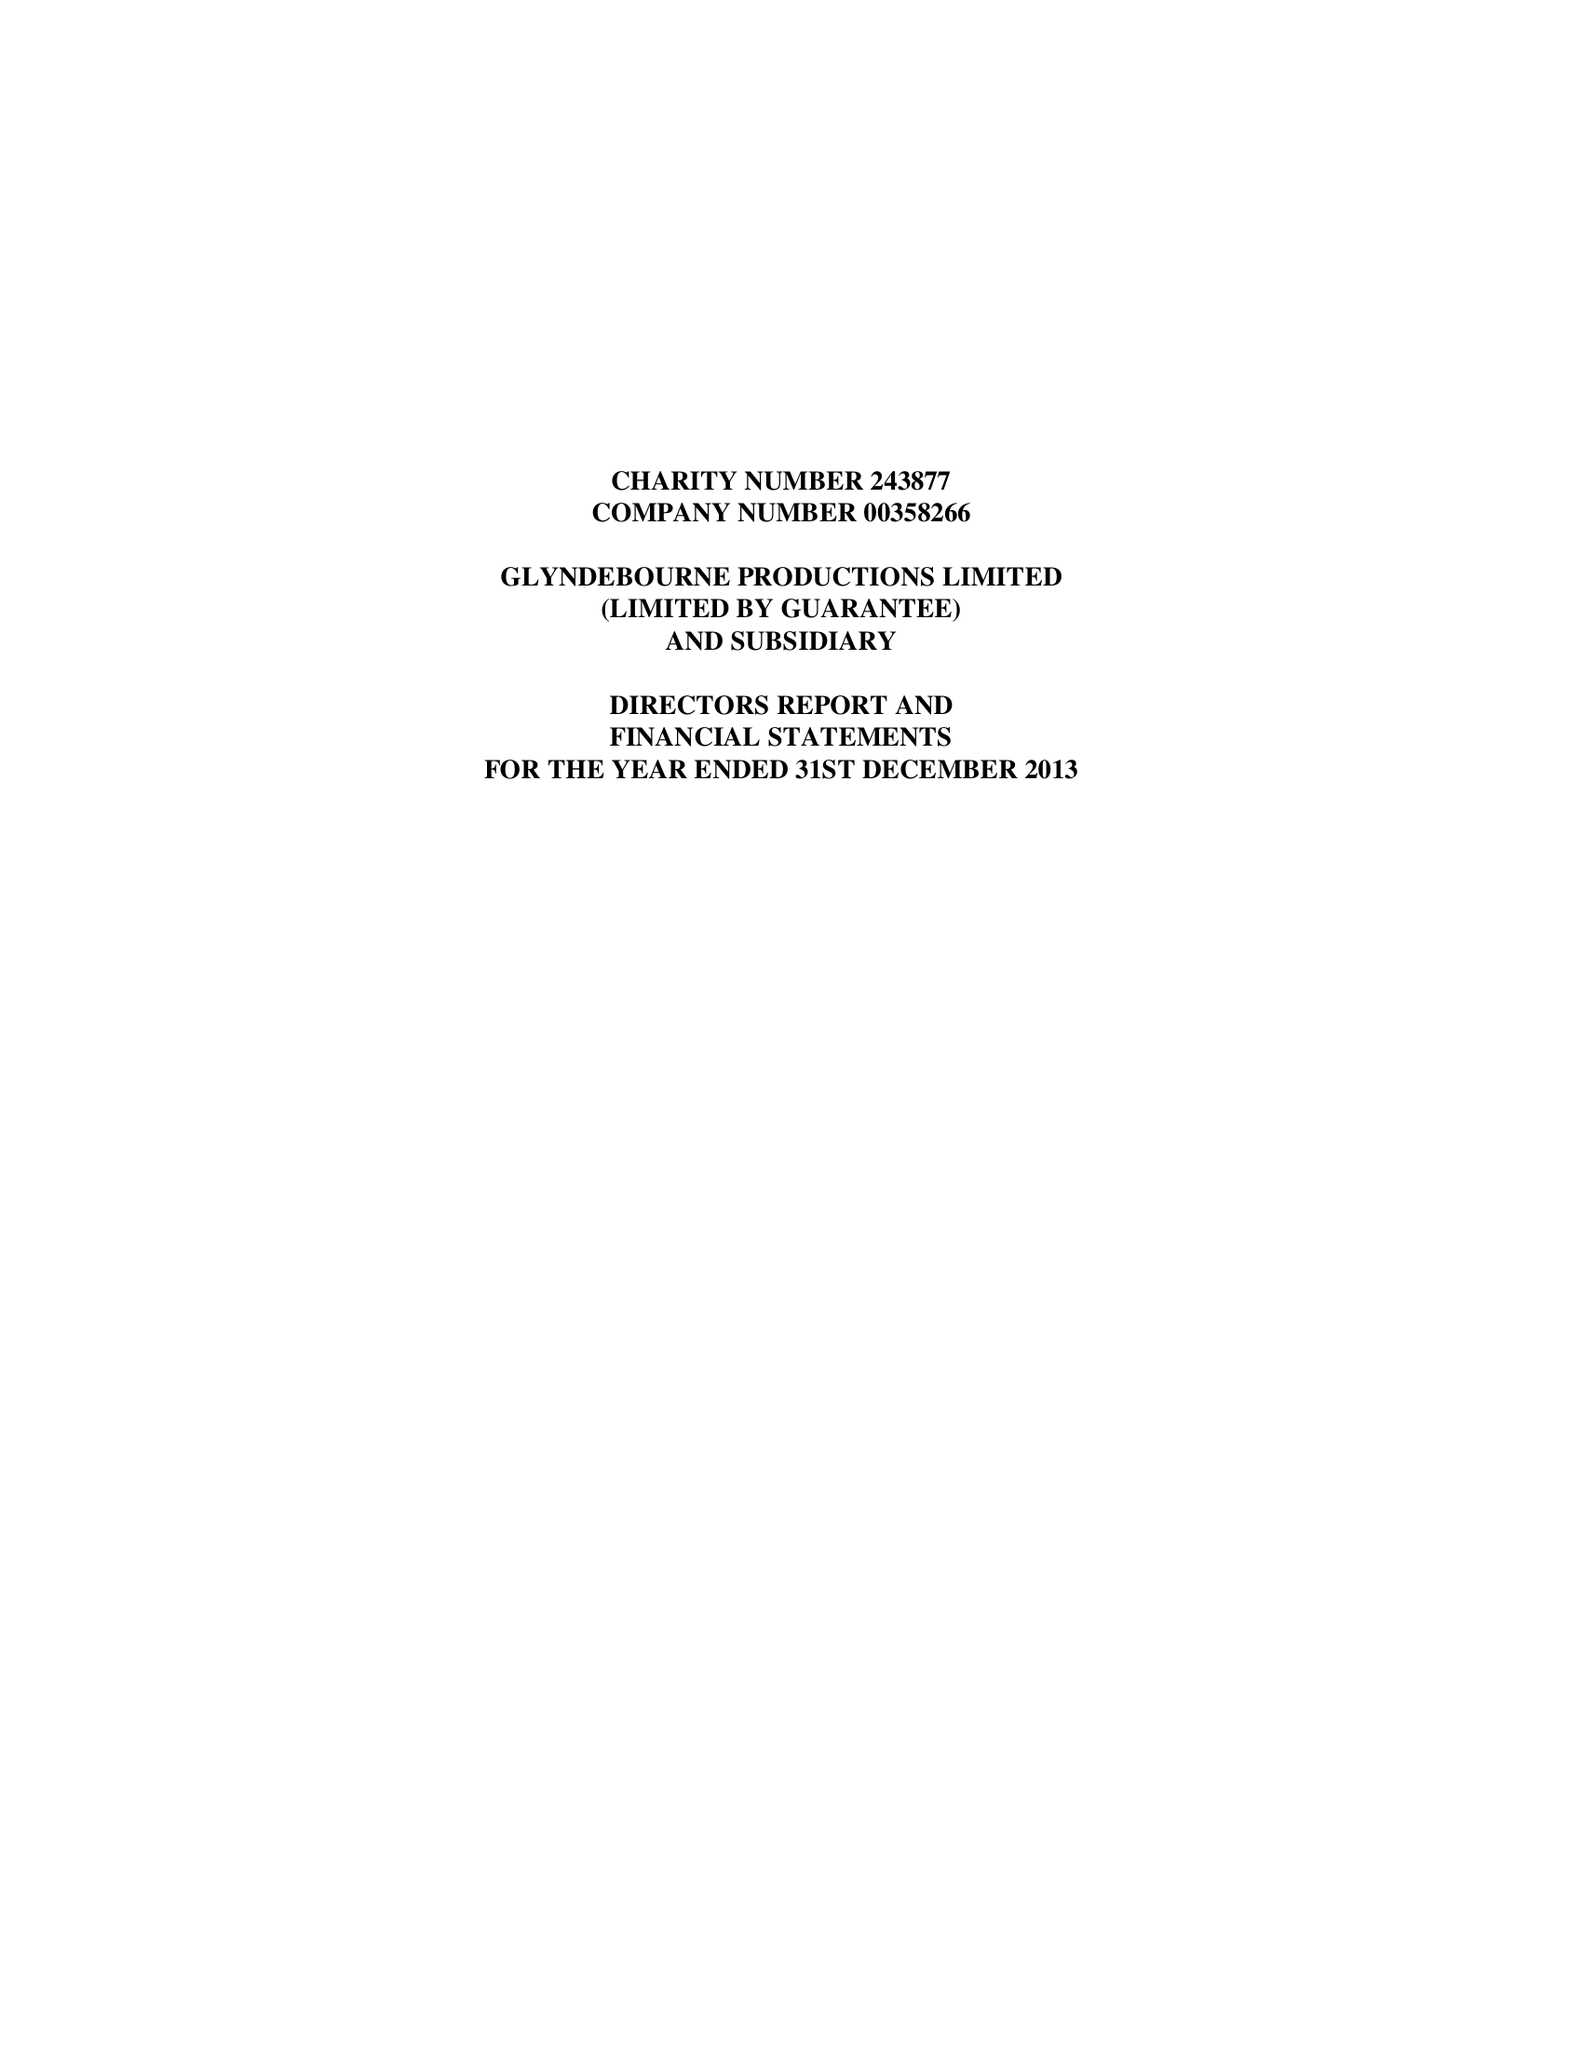What is the value for the address__post_town?
Answer the question using a single word or phrase. LEWES 